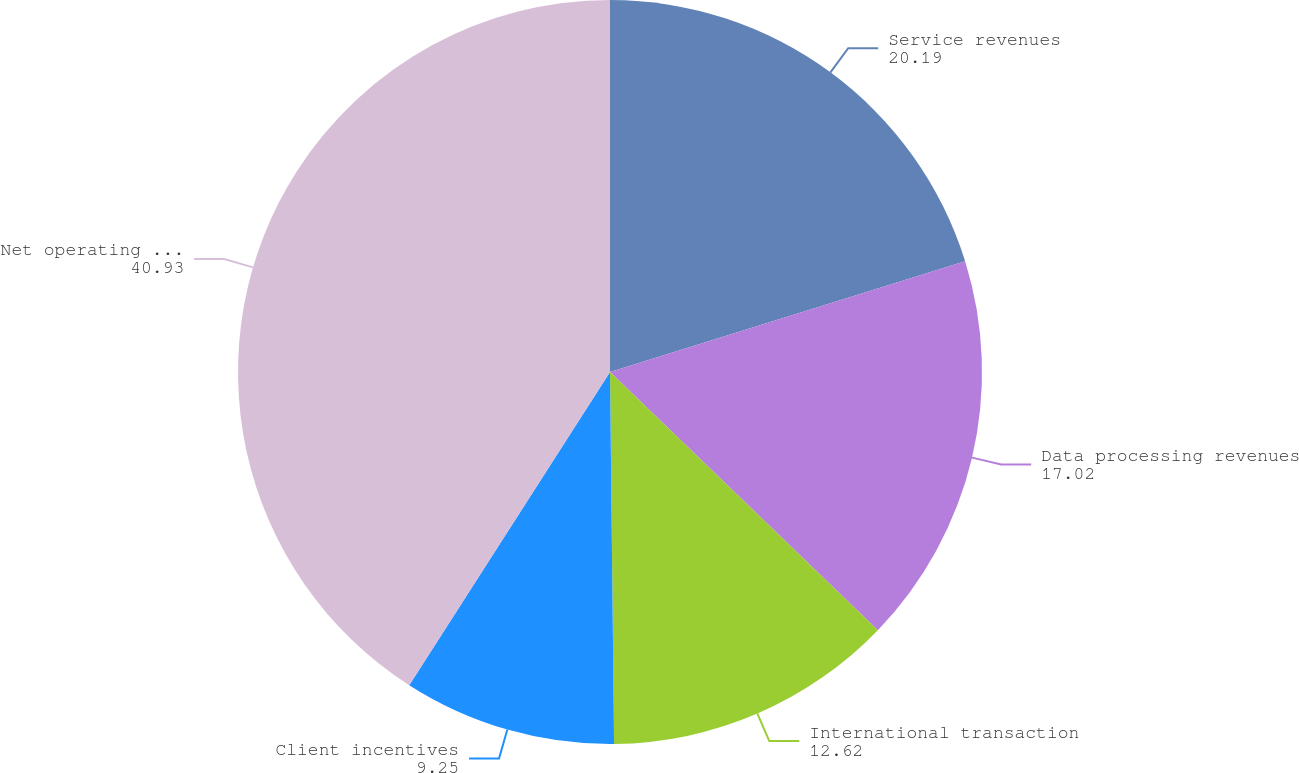Convert chart. <chart><loc_0><loc_0><loc_500><loc_500><pie_chart><fcel>Service revenues<fcel>Data processing revenues<fcel>International transaction<fcel>Client incentives<fcel>Net operating revenues<nl><fcel>20.19%<fcel>17.02%<fcel>12.62%<fcel>9.25%<fcel>40.93%<nl></chart> 